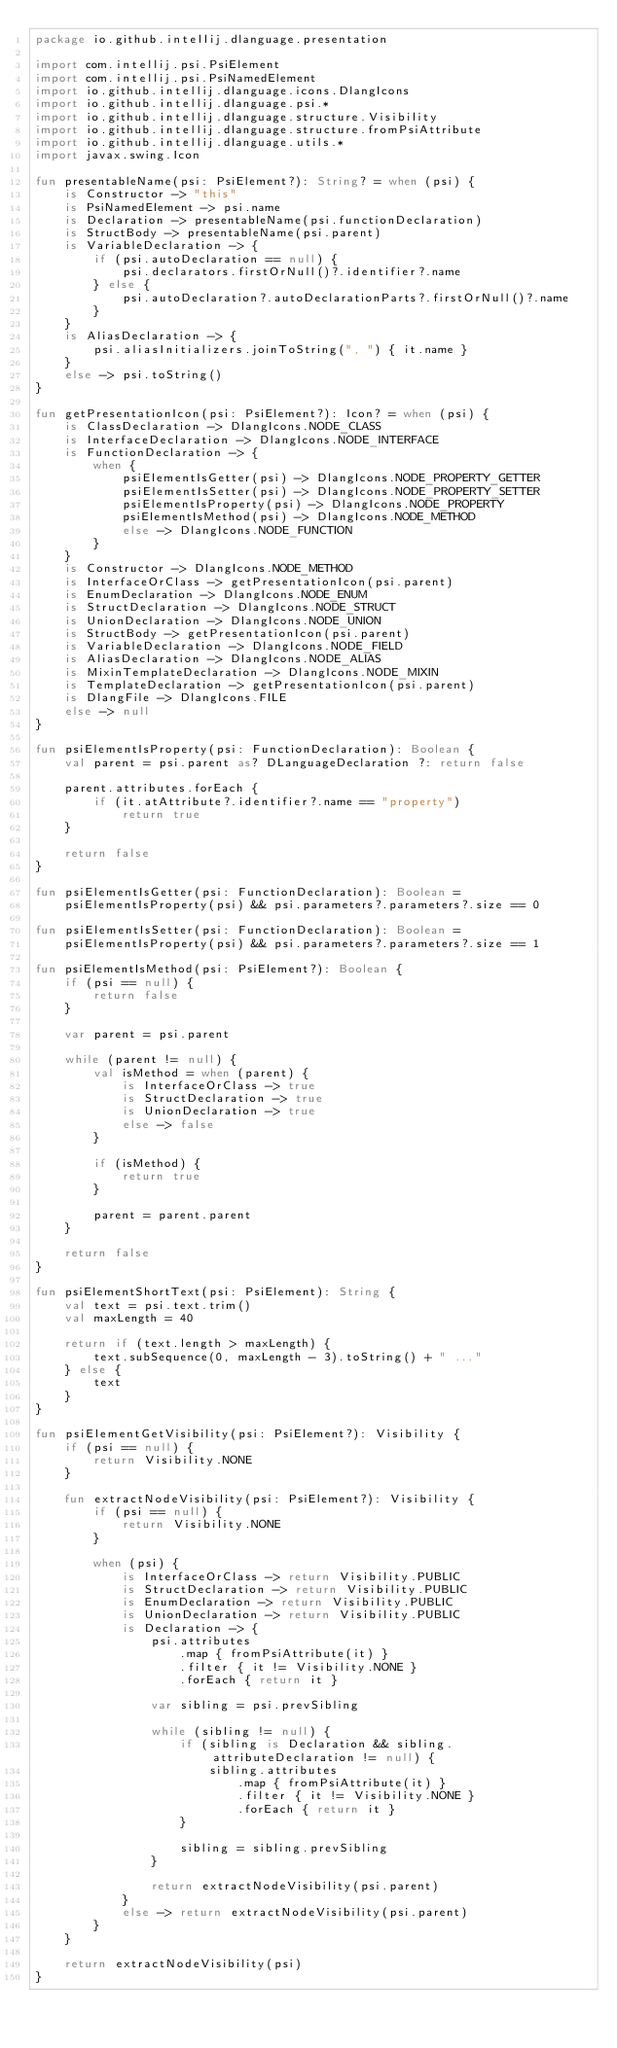Convert code to text. <code><loc_0><loc_0><loc_500><loc_500><_Kotlin_>package io.github.intellij.dlanguage.presentation

import com.intellij.psi.PsiElement
import com.intellij.psi.PsiNamedElement
import io.github.intellij.dlanguage.icons.DlangIcons
import io.github.intellij.dlanguage.psi.*
import io.github.intellij.dlanguage.structure.Visibility
import io.github.intellij.dlanguage.structure.fromPsiAttribute
import io.github.intellij.dlanguage.utils.*
import javax.swing.Icon

fun presentableName(psi: PsiElement?): String? = when (psi) {
    is Constructor -> "this"
    is PsiNamedElement -> psi.name
    is Declaration -> presentableName(psi.functionDeclaration)
    is StructBody -> presentableName(psi.parent)
    is VariableDeclaration -> {
        if (psi.autoDeclaration == null) {
            psi.declarators.firstOrNull()?.identifier?.name
        } else {
            psi.autoDeclaration?.autoDeclarationParts?.firstOrNull()?.name
        }
    }
    is AliasDeclaration -> {
        psi.aliasInitializers.joinToString(", ") { it.name }
    }
    else -> psi.toString()
}

fun getPresentationIcon(psi: PsiElement?): Icon? = when (psi) {
    is ClassDeclaration -> DlangIcons.NODE_CLASS
    is InterfaceDeclaration -> DlangIcons.NODE_INTERFACE
    is FunctionDeclaration -> {
        when {
            psiElementIsGetter(psi) -> DlangIcons.NODE_PROPERTY_GETTER
            psiElementIsSetter(psi) -> DlangIcons.NODE_PROPERTY_SETTER
            psiElementIsProperty(psi) -> DlangIcons.NODE_PROPERTY
            psiElementIsMethod(psi) -> DlangIcons.NODE_METHOD
            else -> DlangIcons.NODE_FUNCTION
        }
    }
    is Constructor -> DlangIcons.NODE_METHOD
    is InterfaceOrClass -> getPresentationIcon(psi.parent)
    is EnumDeclaration -> DlangIcons.NODE_ENUM
    is StructDeclaration -> DlangIcons.NODE_STRUCT
    is UnionDeclaration -> DlangIcons.NODE_UNION
    is StructBody -> getPresentationIcon(psi.parent)
    is VariableDeclaration -> DlangIcons.NODE_FIELD
    is AliasDeclaration -> DlangIcons.NODE_ALIAS
    is MixinTemplateDeclaration -> DlangIcons.NODE_MIXIN
    is TemplateDeclaration -> getPresentationIcon(psi.parent)
    is DlangFile -> DlangIcons.FILE
    else -> null
}

fun psiElementIsProperty(psi: FunctionDeclaration): Boolean {
    val parent = psi.parent as? DLanguageDeclaration ?: return false

    parent.attributes.forEach {
        if (it.atAttribute?.identifier?.name == "property")
            return true
    }

    return false
}

fun psiElementIsGetter(psi: FunctionDeclaration): Boolean =
    psiElementIsProperty(psi) && psi.parameters?.parameters?.size == 0

fun psiElementIsSetter(psi: FunctionDeclaration): Boolean =
    psiElementIsProperty(psi) && psi.parameters?.parameters?.size == 1

fun psiElementIsMethod(psi: PsiElement?): Boolean {
    if (psi == null) {
        return false
    }

    var parent = psi.parent

    while (parent != null) {
        val isMethod = when (parent) {
            is InterfaceOrClass -> true
            is StructDeclaration -> true
            is UnionDeclaration -> true
            else -> false
        }

        if (isMethod) {
            return true
        }

        parent = parent.parent
    }

    return false
}

fun psiElementShortText(psi: PsiElement): String {
    val text = psi.text.trim()
    val maxLength = 40

    return if (text.length > maxLength) {
        text.subSequence(0, maxLength - 3).toString() + " ..."
    } else {
        text
    }
}

fun psiElementGetVisibility(psi: PsiElement?): Visibility {
    if (psi == null) {
        return Visibility.NONE
    }

    fun extractNodeVisibility(psi: PsiElement?): Visibility {
        if (psi == null) {
            return Visibility.NONE
        }

        when (psi) {
            is InterfaceOrClass -> return Visibility.PUBLIC
            is StructDeclaration -> return Visibility.PUBLIC
            is EnumDeclaration -> return Visibility.PUBLIC
            is UnionDeclaration -> return Visibility.PUBLIC
            is Declaration -> {
                psi.attributes
                    .map { fromPsiAttribute(it) }
                    .filter { it != Visibility.NONE }
                    .forEach { return it }

                var sibling = psi.prevSibling

                while (sibling != null) {
                    if (sibling is Declaration && sibling.attributeDeclaration != null) {
                        sibling.attributes
                            .map { fromPsiAttribute(it) }
                            .filter { it != Visibility.NONE }
                            .forEach { return it }
                    }

                    sibling = sibling.prevSibling
                }

                return extractNodeVisibility(psi.parent)
            }
            else -> return extractNodeVisibility(psi.parent)
        }
    }

    return extractNodeVisibility(psi)
}
</code> 